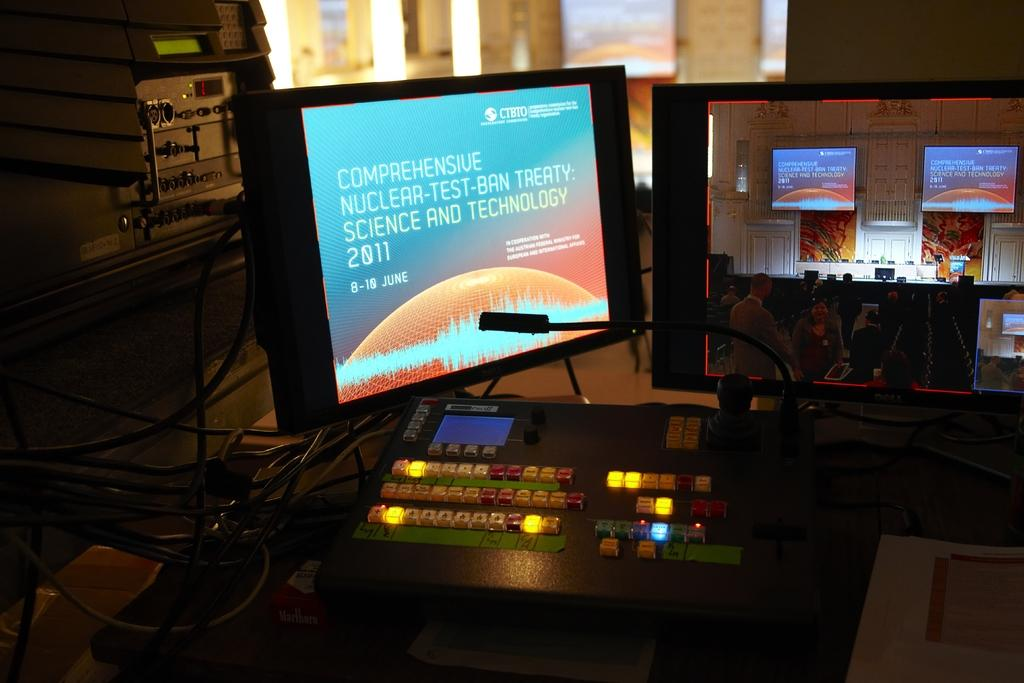<image>
Present a compact description of the photo's key features. Two computer monitors with one showing a message from "CTBTO". 